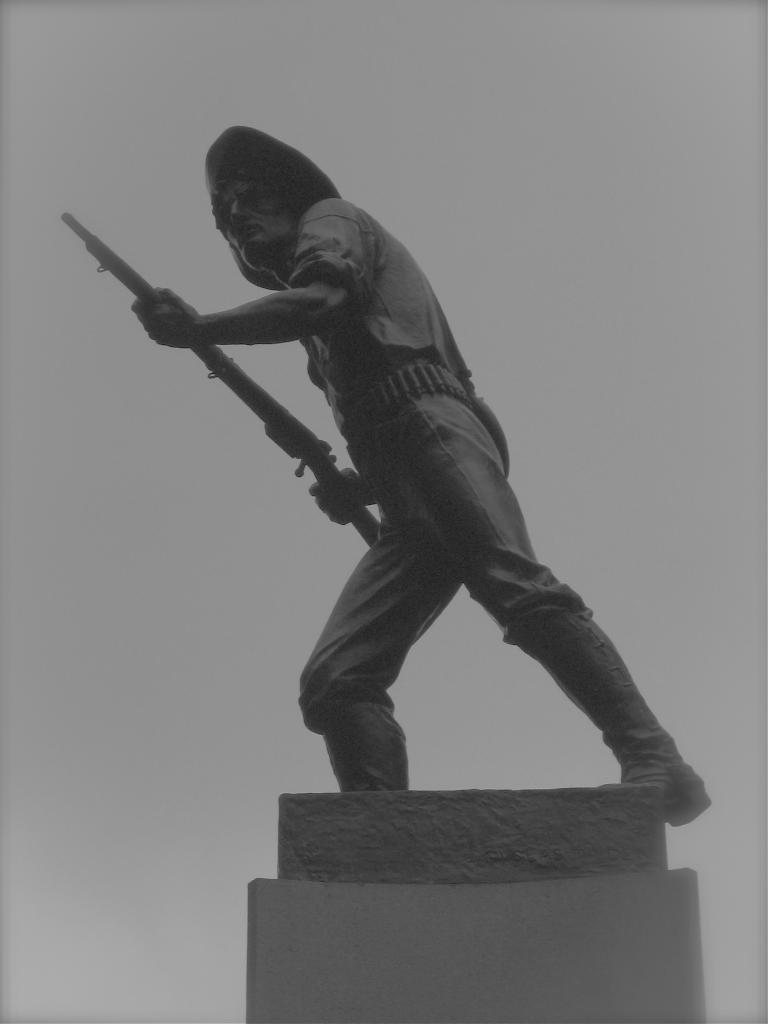What is the color scheme of the image? The image is black and white. What can be seen in the image besides the color scheme? There is a sculpture of a person in the image. What is the person in the sculpture doing? The person is standing on a pillar and holding a weapon. What type of lumber is being used to construct the pillar in the image? There is no lumber present in the image, as it is a sculpture and not a real-life construction. Can you tell me how many keys the person in the sculpture is holding? There are no keys visible in the image; the person is holding a weapon. 